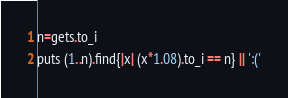<code> <loc_0><loc_0><loc_500><loc_500><_Ruby_>n=gets.to_i
puts (1..n).find{|x| (x*1.08).to_i == n} || ':('</code> 